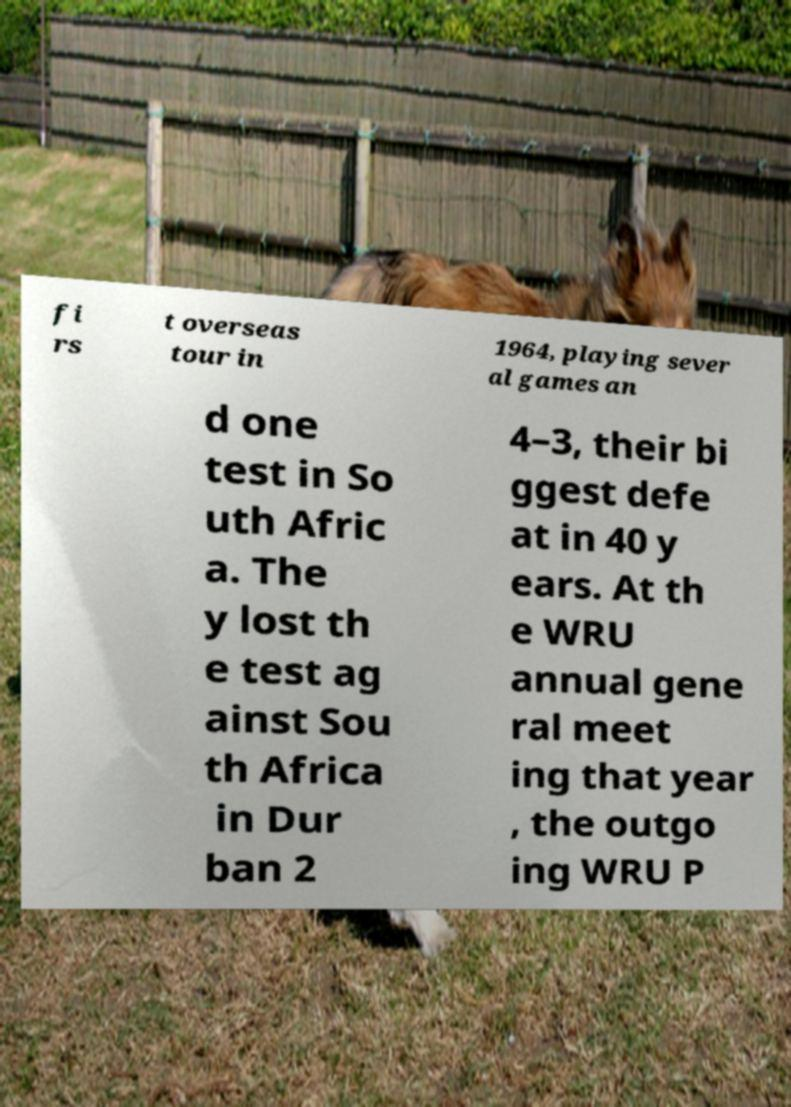Please identify and transcribe the text found in this image. fi rs t overseas tour in 1964, playing sever al games an d one test in So uth Afric a. The y lost th e test ag ainst Sou th Africa in Dur ban 2 4–3, their bi ggest defe at in 40 y ears. At th e WRU annual gene ral meet ing that year , the outgo ing WRU P 